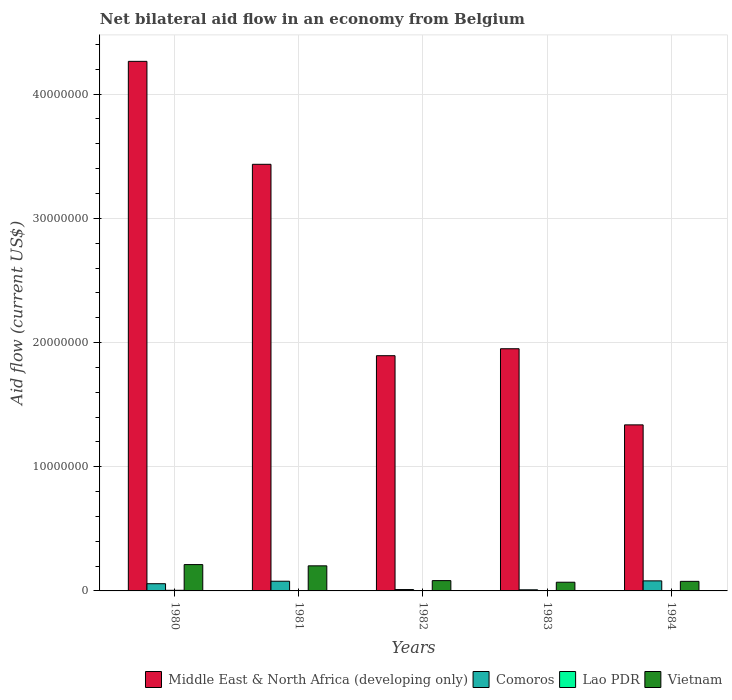Are the number of bars per tick equal to the number of legend labels?
Give a very brief answer. Yes. How many bars are there on the 5th tick from the left?
Provide a succinct answer. 4. What is the label of the 2nd group of bars from the left?
Provide a short and direct response. 1981. What is the net bilateral aid flow in Comoros in 1982?
Your response must be concise. 1.10e+05. Across all years, what is the maximum net bilateral aid flow in Vietnam?
Offer a terse response. 2.12e+06. Across all years, what is the minimum net bilateral aid flow in Middle East & North Africa (developing only)?
Offer a very short reply. 1.34e+07. In which year was the net bilateral aid flow in Vietnam maximum?
Provide a short and direct response. 1980. In which year was the net bilateral aid flow in Vietnam minimum?
Offer a very short reply. 1983. What is the total net bilateral aid flow in Middle East & North Africa (developing only) in the graph?
Your response must be concise. 1.29e+08. What is the difference between the net bilateral aid flow in Middle East & North Africa (developing only) in 1980 and that in 1983?
Provide a succinct answer. 2.31e+07. What is the difference between the net bilateral aid flow in Vietnam in 1982 and the net bilateral aid flow in Middle East & North Africa (developing only) in 1980?
Make the answer very short. -4.18e+07. What is the average net bilateral aid flow in Middle East & North Africa (developing only) per year?
Your answer should be compact. 2.58e+07. In the year 1984, what is the difference between the net bilateral aid flow in Middle East & North Africa (developing only) and net bilateral aid flow in Vietnam?
Keep it short and to the point. 1.26e+07. What is the ratio of the net bilateral aid flow in Lao PDR in 1982 to that in 1983?
Your response must be concise. 3. What is the difference between the highest and the lowest net bilateral aid flow in Lao PDR?
Your response must be concise. 4.00e+04. Is the sum of the net bilateral aid flow in Middle East & North Africa (developing only) in 1981 and 1983 greater than the maximum net bilateral aid flow in Comoros across all years?
Your response must be concise. Yes. What does the 1st bar from the left in 1980 represents?
Your response must be concise. Middle East & North Africa (developing only). What does the 3rd bar from the right in 1983 represents?
Offer a very short reply. Comoros. How many bars are there?
Your answer should be very brief. 20. Are all the bars in the graph horizontal?
Offer a very short reply. No. How many years are there in the graph?
Give a very brief answer. 5. Are the values on the major ticks of Y-axis written in scientific E-notation?
Provide a short and direct response. No. Does the graph contain any zero values?
Give a very brief answer. No. Where does the legend appear in the graph?
Keep it short and to the point. Bottom right. How many legend labels are there?
Offer a very short reply. 4. How are the legend labels stacked?
Offer a terse response. Horizontal. What is the title of the graph?
Make the answer very short. Net bilateral aid flow in an economy from Belgium. Does "Ghana" appear as one of the legend labels in the graph?
Ensure brevity in your answer.  No. What is the label or title of the X-axis?
Your answer should be compact. Years. What is the Aid flow (current US$) in Middle East & North Africa (developing only) in 1980?
Provide a short and direct response. 4.26e+07. What is the Aid flow (current US$) in Comoros in 1980?
Give a very brief answer. 5.80e+05. What is the Aid flow (current US$) in Vietnam in 1980?
Your answer should be compact. 2.12e+06. What is the Aid flow (current US$) of Middle East & North Africa (developing only) in 1981?
Keep it short and to the point. 3.44e+07. What is the Aid flow (current US$) of Comoros in 1981?
Offer a terse response. 7.80e+05. What is the Aid flow (current US$) of Lao PDR in 1981?
Provide a succinct answer. 10000. What is the Aid flow (current US$) in Vietnam in 1981?
Provide a succinct answer. 2.02e+06. What is the Aid flow (current US$) in Middle East & North Africa (developing only) in 1982?
Provide a short and direct response. 1.89e+07. What is the Aid flow (current US$) in Comoros in 1982?
Offer a terse response. 1.10e+05. What is the Aid flow (current US$) in Vietnam in 1982?
Make the answer very short. 8.30e+05. What is the Aid flow (current US$) of Middle East & North Africa (developing only) in 1983?
Keep it short and to the point. 1.95e+07. What is the Aid flow (current US$) of Vietnam in 1983?
Give a very brief answer. 7.00e+05. What is the Aid flow (current US$) of Middle East & North Africa (developing only) in 1984?
Ensure brevity in your answer.  1.34e+07. What is the Aid flow (current US$) in Comoros in 1984?
Your response must be concise. 8.10e+05. What is the Aid flow (current US$) in Vietnam in 1984?
Provide a succinct answer. 7.70e+05. Across all years, what is the maximum Aid flow (current US$) of Middle East & North Africa (developing only)?
Your response must be concise. 4.26e+07. Across all years, what is the maximum Aid flow (current US$) in Comoros?
Ensure brevity in your answer.  8.10e+05. Across all years, what is the maximum Aid flow (current US$) in Lao PDR?
Give a very brief answer. 5.00e+04. Across all years, what is the maximum Aid flow (current US$) in Vietnam?
Provide a succinct answer. 2.12e+06. Across all years, what is the minimum Aid flow (current US$) in Middle East & North Africa (developing only)?
Offer a terse response. 1.34e+07. Across all years, what is the minimum Aid flow (current US$) in Lao PDR?
Provide a short and direct response. 10000. What is the total Aid flow (current US$) of Middle East & North Africa (developing only) in the graph?
Your answer should be compact. 1.29e+08. What is the total Aid flow (current US$) in Comoros in the graph?
Provide a short and direct response. 2.37e+06. What is the total Aid flow (current US$) of Lao PDR in the graph?
Provide a succinct answer. 1.20e+05. What is the total Aid flow (current US$) of Vietnam in the graph?
Offer a very short reply. 6.44e+06. What is the difference between the Aid flow (current US$) in Middle East & North Africa (developing only) in 1980 and that in 1981?
Provide a short and direct response. 8.29e+06. What is the difference between the Aid flow (current US$) in Middle East & North Africa (developing only) in 1980 and that in 1982?
Provide a short and direct response. 2.37e+07. What is the difference between the Aid flow (current US$) of Comoros in 1980 and that in 1982?
Offer a terse response. 4.70e+05. What is the difference between the Aid flow (current US$) of Vietnam in 1980 and that in 1982?
Keep it short and to the point. 1.29e+06. What is the difference between the Aid flow (current US$) of Middle East & North Africa (developing only) in 1980 and that in 1983?
Offer a very short reply. 2.31e+07. What is the difference between the Aid flow (current US$) of Comoros in 1980 and that in 1983?
Your response must be concise. 4.90e+05. What is the difference between the Aid flow (current US$) of Vietnam in 1980 and that in 1983?
Your answer should be compact. 1.42e+06. What is the difference between the Aid flow (current US$) in Middle East & North Africa (developing only) in 1980 and that in 1984?
Your answer should be compact. 2.93e+07. What is the difference between the Aid flow (current US$) of Comoros in 1980 and that in 1984?
Ensure brevity in your answer.  -2.30e+05. What is the difference between the Aid flow (current US$) in Vietnam in 1980 and that in 1984?
Offer a terse response. 1.35e+06. What is the difference between the Aid flow (current US$) of Middle East & North Africa (developing only) in 1981 and that in 1982?
Ensure brevity in your answer.  1.54e+07. What is the difference between the Aid flow (current US$) in Comoros in 1981 and that in 1982?
Your response must be concise. 6.70e+05. What is the difference between the Aid flow (current US$) of Lao PDR in 1981 and that in 1982?
Offer a terse response. -2.00e+04. What is the difference between the Aid flow (current US$) of Vietnam in 1981 and that in 1982?
Your answer should be compact. 1.19e+06. What is the difference between the Aid flow (current US$) in Middle East & North Africa (developing only) in 1981 and that in 1983?
Your response must be concise. 1.48e+07. What is the difference between the Aid flow (current US$) in Comoros in 1981 and that in 1983?
Make the answer very short. 6.90e+05. What is the difference between the Aid flow (current US$) of Vietnam in 1981 and that in 1983?
Keep it short and to the point. 1.32e+06. What is the difference between the Aid flow (current US$) of Middle East & North Africa (developing only) in 1981 and that in 1984?
Provide a short and direct response. 2.10e+07. What is the difference between the Aid flow (current US$) in Comoros in 1981 and that in 1984?
Offer a very short reply. -3.00e+04. What is the difference between the Aid flow (current US$) of Lao PDR in 1981 and that in 1984?
Make the answer very short. -10000. What is the difference between the Aid flow (current US$) in Vietnam in 1981 and that in 1984?
Provide a succinct answer. 1.25e+06. What is the difference between the Aid flow (current US$) in Middle East & North Africa (developing only) in 1982 and that in 1983?
Offer a very short reply. -5.60e+05. What is the difference between the Aid flow (current US$) in Lao PDR in 1982 and that in 1983?
Make the answer very short. 2.00e+04. What is the difference between the Aid flow (current US$) of Middle East & North Africa (developing only) in 1982 and that in 1984?
Give a very brief answer. 5.57e+06. What is the difference between the Aid flow (current US$) in Comoros in 1982 and that in 1984?
Ensure brevity in your answer.  -7.00e+05. What is the difference between the Aid flow (current US$) in Middle East & North Africa (developing only) in 1983 and that in 1984?
Your response must be concise. 6.13e+06. What is the difference between the Aid flow (current US$) in Comoros in 1983 and that in 1984?
Keep it short and to the point. -7.20e+05. What is the difference between the Aid flow (current US$) in Lao PDR in 1983 and that in 1984?
Offer a terse response. -10000. What is the difference between the Aid flow (current US$) of Vietnam in 1983 and that in 1984?
Your answer should be compact. -7.00e+04. What is the difference between the Aid flow (current US$) of Middle East & North Africa (developing only) in 1980 and the Aid flow (current US$) of Comoros in 1981?
Make the answer very short. 4.19e+07. What is the difference between the Aid flow (current US$) of Middle East & North Africa (developing only) in 1980 and the Aid flow (current US$) of Lao PDR in 1981?
Ensure brevity in your answer.  4.26e+07. What is the difference between the Aid flow (current US$) of Middle East & North Africa (developing only) in 1980 and the Aid flow (current US$) of Vietnam in 1981?
Give a very brief answer. 4.06e+07. What is the difference between the Aid flow (current US$) in Comoros in 1980 and the Aid flow (current US$) in Lao PDR in 1981?
Ensure brevity in your answer.  5.70e+05. What is the difference between the Aid flow (current US$) in Comoros in 1980 and the Aid flow (current US$) in Vietnam in 1981?
Provide a succinct answer. -1.44e+06. What is the difference between the Aid flow (current US$) in Lao PDR in 1980 and the Aid flow (current US$) in Vietnam in 1981?
Ensure brevity in your answer.  -1.97e+06. What is the difference between the Aid flow (current US$) in Middle East & North Africa (developing only) in 1980 and the Aid flow (current US$) in Comoros in 1982?
Your answer should be very brief. 4.25e+07. What is the difference between the Aid flow (current US$) of Middle East & North Africa (developing only) in 1980 and the Aid flow (current US$) of Lao PDR in 1982?
Keep it short and to the point. 4.26e+07. What is the difference between the Aid flow (current US$) in Middle East & North Africa (developing only) in 1980 and the Aid flow (current US$) in Vietnam in 1982?
Keep it short and to the point. 4.18e+07. What is the difference between the Aid flow (current US$) of Comoros in 1980 and the Aid flow (current US$) of Lao PDR in 1982?
Give a very brief answer. 5.50e+05. What is the difference between the Aid flow (current US$) of Lao PDR in 1980 and the Aid flow (current US$) of Vietnam in 1982?
Give a very brief answer. -7.80e+05. What is the difference between the Aid flow (current US$) in Middle East & North Africa (developing only) in 1980 and the Aid flow (current US$) in Comoros in 1983?
Your answer should be compact. 4.26e+07. What is the difference between the Aid flow (current US$) in Middle East & North Africa (developing only) in 1980 and the Aid flow (current US$) in Lao PDR in 1983?
Your response must be concise. 4.26e+07. What is the difference between the Aid flow (current US$) in Middle East & North Africa (developing only) in 1980 and the Aid flow (current US$) in Vietnam in 1983?
Provide a short and direct response. 4.19e+07. What is the difference between the Aid flow (current US$) in Comoros in 1980 and the Aid flow (current US$) in Lao PDR in 1983?
Your answer should be compact. 5.70e+05. What is the difference between the Aid flow (current US$) in Lao PDR in 1980 and the Aid flow (current US$) in Vietnam in 1983?
Provide a short and direct response. -6.50e+05. What is the difference between the Aid flow (current US$) of Middle East & North Africa (developing only) in 1980 and the Aid flow (current US$) of Comoros in 1984?
Give a very brief answer. 4.18e+07. What is the difference between the Aid flow (current US$) in Middle East & North Africa (developing only) in 1980 and the Aid flow (current US$) in Lao PDR in 1984?
Keep it short and to the point. 4.26e+07. What is the difference between the Aid flow (current US$) in Middle East & North Africa (developing only) in 1980 and the Aid flow (current US$) in Vietnam in 1984?
Provide a succinct answer. 4.19e+07. What is the difference between the Aid flow (current US$) of Comoros in 1980 and the Aid flow (current US$) of Lao PDR in 1984?
Provide a succinct answer. 5.60e+05. What is the difference between the Aid flow (current US$) in Comoros in 1980 and the Aid flow (current US$) in Vietnam in 1984?
Provide a succinct answer. -1.90e+05. What is the difference between the Aid flow (current US$) of Lao PDR in 1980 and the Aid flow (current US$) of Vietnam in 1984?
Your answer should be compact. -7.20e+05. What is the difference between the Aid flow (current US$) of Middle East & North Africa (developing only) in 1981 and the Aid flow (current US$) of Comoros in 1982?
Your answer should be very brief. 3.42e+07. What is the difference between the Aid flow (current US$) of Middle East & North Africa (developing only) in 1981 and the Aid flow (current US$) of Lao PDR in 1982?
Offer a terse response. 3.43e+07. What is the difference between the Aid flow (current US$) of Middle East & North Africa (developing only) in 1981 and the Aid flow (current US$) of Vietnam in 1982?
Your answer should be compact. 3.35e+07. What is the difference between the Aid flow (current US$) in Comoros in 1981 and the Aid flow (current US$) in Lao PDR in 1982?
Your answer should be very brief. 7.50e+05. What is the difference between the Aid flow (current US$) of Lao PDR in 1981 and the Aid flow (current US$) of Vietnam in 1982?
Your answer should be very brief. -8.20e+05. What is the difference between the Aid flow (current US$) in Middle East & North Africa (developing only) in 1981 and the Aid flow (current US$) in Comoros in 1983?
Provide a succinct answer. 3.43e+07. What is the difference between the Aid flow (current US$) in Middle East & North Africa (developing only) in 1981 and the Aid flow (current US$) in Lao PDR in 1983?
Your response must be concise. 3.43e+07. What is the difference between the Aid flow (current US$) of Middle East & North Africa (developing only) in 1981 and the Aid flow (current US$) of Vietnam in 1983?
Provide a succinct answer. 3.36e+07. What is the difference between the Aid flow (current US$) in Comoros in 1981 and the Aid flow (current US$) in Lao PDR in 1983?
Offer a very short reply. 7.70e+05. What is the difference between the Aid flow (current US$) of Comoros in 1981 and the Aid flow (current US$) of Vietnam in 1983?
Your answer should be compact. 8.00e+04. What is the difference between the Aid flow (current US$) of Lao PDR in 1981 and the Aid flow (current US$) of Vietnam in 1983?
Ensure brevity in your answer.  -6.90e+05. What is the difference between the Aid flow (current US$) in Middle East & North Africa (developing only) in 1981 and the Aid flow (current US$) in Comoros in 1984?
Offer a very short reply. 3.35e+07. What is the difference between the Aid flow (current US$) of Middle East & North Africa (developing only) in 1981 and the Aid flow (current US$) of Lao PDR in 1984?
Your response must be concise. 3.43e+07. What is the difference between the Aid flow (current US$) in Middle East & North Africa (developing only) in 1981 and the Aid flow (current US$) in Vietnam in 1984?
Make the answer very short. 3.36e+07. What is the difference between the Aid flow (current US$) of Comoros in 1981 and the Aid flow (current US$) of Lao PDR in 1984?
Provide a succinct answer. 7.60e+05. What is the difference between the Aid flow (current US$) in Lao PDR in 1981 and the Aid flow (current US$) in Vietnam in 1984?
Your answer should be very brief. -7.60e+05. What is the difference between the Aid flow (current US$) of Middle East & North Africa (developing only) in 1982 and the Aid flow (current US$) of Comoros in 1983?
Provide a succinct answer. 1.88e+07. What is the difference between the Aid flow (current US$) of Middle East & North Africa (developing only) in 1982 and the Aid flow (current US$) of Lao PDR in 1983?
Give a very brief answer. 1.89e+07. What is the difference between the Aid flow (current US$) in Middle East & North Africa (developing only) in 1982 and the Aid flow (current US$) in Vietnam in 1983?
Ensure brevity in your answer.  1.82e+07. What is the difference between the Aid flow (current US$) in Comoros in 1982 and the Aid flow (current US$) in Lao PDR in 1983?
Your answer should be compact. 1.00e+05. What is the difference between the Aid flow (current US$) of Comoros in 1982 and the Aid flow (current US$) of Vietnam in 1983?
Offer a terse response. -5.90e+05. What is the difference between the Aid flow (current US$) in Lao PDR in 1982 and the Aid flow (current US$) in Vietnam in 1983?
Give a very brief answer. -6.70e+05. What is the difference between the Aid flow (current US$) of Middle East & North Africa (developing only) in 1982 and the Aid flow (current US$) of Comoros in 1984?
Provide a short and direct response. 1.81e+07. What is the difference between the Aid flow (current US$) in Middle East & North Africa (developing only) in 1982 and the Aid flow (current US$) in Lao PDR in 1984?
Offer a terse response. 1.89e+07. What is the difference between the Aid flow (current US$) of Middle East & North Africa (developing only) in 1982 and the Aid flow (current US$) of Vietnam in 1984?
Make the answer very short. 1.82e+07. What is the difference between the Aid flow (current US$) in Comoros in 1982 and the Aid flow (current US$) in Vietnam in 1984?
Keep it short and to the point. -6.60e+05. What is the difference between the Aid flow (current US$) of Lao PDR in 1982 and the Aid flow (current US$) of Vietnam in 1984?
Provide a short and direct response. -7.40e+05. What is the difference between the Aid flow (current US$) in Middle East & North Africa (developing only) in 1983 and the Aid flow (current US$) in Comoros in 1984?
Provide a short and direct response. 1.87e+07. What is the difference between the Aid flow (current US$) of Middle East & North Africa (developing only) in 1983 and the Aid flow (current US$) of Lao PDR in 1984?
Your answer should be very brief. 1.95e+07. What is the difference between the Aid flow (current US$) of Middle East & North Africa (developing only) in 1983 and the Aid flow (current US$) of Vietnam in 1984?
Your answer should be very brief. 1.87e+07. What is the difference between the Aid flow (current US$) in Comoros in 1983 and the Aid flow (current US$) in Lao PDR in 1984?
Make the answer very short. 7.00e+04. What is the difference between the Aid flow (current US$) of Comoros in 1983 and the Aid flow (current US$) of Vietnam in 1984?
Ensure brevity in your answer.  -6.80e+05. What is the difference between the Aid flow (current US$) in Lao PDR in 1983 and the Aid flow (current US$) in Vietnam in 1984?
Provide a short and direct response. -7.60e+05. What is the average Aid flow (current US$) in Middle East & North Africa (developing only) per year?
Offer a very short reply. 2.58e+07. What is the average Aid flow (current US$) of Comoros per year?
Make the answer very short. 4.74e+05. What is the average Aid flow (current US$) in Lao PDR per year?
Provide a succinct answer. 2.40e+04. What is the average Aid flow (current US$) in Vietnam per year?
Your response must be concise. 1.29e+06. In the year 1980, what is the difference between the Aid flow (current US$) in Middle East & North Africa (developing only) and Aid flow (current US$) in Comoros?
Make the answer very short. 4.21e+07. In the year 1980, what is the difference between the Aid flow (current US$) in Middle East & North Africa (developing only) and Aid flow (current US$) in Lao PDR?
Your answer should be compact. 4.26e+07. In the year 1980, what is the difference between the Aid flow (current US$) in Middle East & North Africa (developing only) and Aid flow (current US$) in Vietnam?
Your response must be concise. 4.05e+07. In the year 1980, what is the difference between the Aid flow (current US$) in Comoros and Aid flow (current US$) in Lao PDR?
Ensure brevity in your answer.  5.30e+05. In the year 1980, what is the difference between the Aid flow (current US$) in Comoros and Aid flow (current US$) in Vietnam?
Keep it short and to the point. -1.54e+06. In the year 1980, what is the difference between the Aid flow (current US$) of Lao PDR and Aid flow (current US$) of Vietnam?
Provide a succinct answer. -2.07e+06. In the year 1981, what is the difference between the Aid flow (current US$) of Middle East & North Africa (developing only) and Aid flow (current US$) of Comoros?
Provide a short and direct response. 3.36e+07. In the year 1981, what is the difference between the Aid flow (current US$) in Middle East & North Africa (developing only) and Aid flow (current US$) in Lao PDR?
Your answer should be compact. 3.43e+07. In the year 1981, what is the difference between the Aid flow (current US$) in Middle East & North Africa (developing only) and Aid flow (current US$) in Vietnam?
Provide a succinct answer. 3.23e+07. In the year 1981, what is the difference between the Aid flow (current US$) in Comoros and Aid flow (current US$) in Lao PDR?
Offer a very short reply. 7.70e+05. In the year 1981, what is the difference between the Aid flow (current US$) of Comoros and Aid flow (current US$) of Vietnam?
Ensure brevity in your answer.  -1.24e+06. In the year 1981, what is the difference between the Aid flow (current US$) of Lao PDR and Aid flow (current US$) of Vietnam?
Your response must be concise. -2.01e+06. In the year 1982, what is the difference between the Aid flow (current US$) in Middle East & North Africa (developing only) and Aid flow (current US$) in Comoros?
Give a very brief answer. 1.88e+07. In the year 1982, what is the difference between the Aid flow (current US$) of Middle East & North Africa (developing only) and Aid flow (current US$) of Lao PDR?
Offer a terse response. 1.89e+07. In the year 1982, what is the difference between the Aid flow (current US$) of Middle East & North Africa (developing only) and Aid flow (current US$) of Vietnam?
Provide a succinct answer. 1.81e+07. In the year 1982, what is the difference between the Aid flow (current US$) of Comoros and Aid flow (current US$) of Vietnam?
Provide a short and direct response. -7.20e+05. In the year 1982, what is the difference between the Aid flow (current US$) of Lao PDR and Aid flow (current US$) of Vietnam?
Offer a very short reply. -8.00e+05. In the year 1983, what is the difference between the Aid flow (current US$) in Middle East & North Africa (developing only) and Aid flow (current US$) in Comoros?
Provide a short and direct response. 1.94e+07. In the year 1983, what is the difference between the Aid flow (current US$) in Middle East & North Africa (developing only) and Aid flow (current US$) in Lao PDR?
Provide a succinct answer. 1.95e+07. In the year 1983, what is the difference between the Aid flow (current US$) of Middle East & North Africa (developing only) and Aid flow (current US$) of Vietnam?
Make the answer very short. 1.88e+07. In the year 1983, what is the difference between the Aid flow (current US$) in Comoros and Aid flow (current US$) in Vietnam?
Give a very brief answer. -6.10e+05. In the year 1983, what is the difference between the Aid flow (current US$) in Lao PDR and Aid flow (current US$) in Vietnam?
Ensure brevity in your answer.  -6.90e+05. In the year 1984, what is the difference between the Aid flow (current US$) of Middle East & North Africa (developing only) and Aid flow (current US$) of Comoros?
Your response must be concise. 1.26e+07. In the year 1984, what is the difference between the Aid flow (current US$) in Middle East & North Africa (developing only) and Aid flow (current US$) in Lao PDR?
Your response must be concise. 1.34e+07. In the year 1984, what is the difference between the Aid flow (current US$) in Middle East & North Africa (developing only) and Aid flow (current US$) in Vietnam?
Offer a very short reply. 1.26e+07. In the year 1984, what is the difference between the Aid flow (current US$) in Comoros and Aid flow (current US$) in Lao PDR?
Your answer should be compact. 7.90e+05. In the year 1984, what is the difference between the Aid flow (current US$) in Comoros and Aid flow (current US$) in Vietnam?
Ensure brevity in your answer.  4.00e+04. In the year 1984, what is the difference between the Aid flow (current US$) of Lao PDR and Aid flow (current US$) of Vietnam?
Your answer should be very brief. -7.50e+05. What is the ratio of the Aid flow (current US$) of Middle East & North Africa (developing only) in 1980 to that in 1981?
Ensure brevity in your answer.  1.24. What is the ratio of the Aid flow (current US$) in Comoros in 1980 to that in 1981?
Provide a short and direct response. 0.74. What is the ratio of the Aid flow (current US$) in Lao PDR in 1980 to that in 1981?
Offer a terse response. 5. What is the ratio of the Aid flow (current US$) in Vietnam in 1980 to that in 1981?
Your answer should be compact. 1.05. What is the ratio of the Aid flow (current US$) in Middle East & North Africa (developing only) in 1980 to that in 1982?
Provide a short and direct response. 2.25. What is the ratio of the Aid flow (current US$) of Comoros in 1980 to that in 1982?
Your answer should be compact. 5.27. What is the ratio of the Aid flow (current US$) in Vietnam in 1980 to that in 1982?
Provide a succinct answer. 2.55. What is the ratio of the Aid flow (current US$) in Middle East & North Africa (developing only) in 1980 to that in 1983?
Keep it short and to the point. 2.19. What is the ratio of the Aid flow (current US$) in Comoros in 1980 to that in 1983?
Your answer should be very brief. 6.44. What is the ratio of the Aid flow (current US$) in Vietnam in 1980 to that in 1983?
Offer a very short reply. 3.03. What is the ratio of the Aid flow (current US$) in Middle East & North Africa (developing only) in 1980 to that in 1984?
Offer a terse response. 3.19. What is the ratio of the Aid flow (current US$) in Comoros in 1980 to that in 1984?
Make the answer very short. 0.72. What is the ratio of the Aid flow (current US$) of Vietnam in 1980 to that in 1984?
Your answer should be compact. 2.75. What is the ratio of the Aid flow (current US$) in Middle East & North Africa (developing only) in 1981 to that in 1982?
Make the answer very short. 1.81. What is the ratio of the Aid flow (current US$) in Comoros in 1981 to that in 1982?
Make the answer very short. 7.09. What is the ratio of the Aid flow (current US$) of Lao PDR in 1981 to that in 1982?
Offer a terse response. 0.33. What is the ratio of the Aid flow (current US$) of Vietnam in 1981 to that in 1982?
Your response must be concise. 2.43. What is the ratio of the Aid flow (current US$) in Middle East & North Africa (developing only) in 1981 to that in 1983?
Your answer should be compact. 1.76. What is the ratio of the Aid flow (current US$) in Comoros in 1981 to that in 1983?
Ensure brevity in your answer.  8.67. What is the ratio of the Aid flow (current US$) of Lao PDR in 1981 to that in 1983?
Your response must be concise. 1. What is the ratio of the Aid flow (current US$) in Vietnam in 1981 to that in 1983?
Offer a very short reply. 2.89. What is the ratio of the Aid flow (current US$) of Middle East & North Africa (developing only) in 1981 to that in 1984?
Ensure brevity in your answer.  2.57. What is the ratio of the Aid flow (current US$) of Comoros in 1981 to that in 1984?
Ensure brevity in your answer.  0.96. What is the ratio of the Aid flow (current US$) of Lao PDR in 1981 to that in 1984?
Keep it short and to the point. 0.5. What is the ratio of the Aid flow (current US$) in Vietnam in 1981 to that in 1984?
Provide a short and direct response. 2.62. What is the ratio of the Aid flow (current US$) in Middle East & North Africa (developing only) in 1982 to that in 1983?
Provide a succinct answer. 0.97. What is the ratio of the Aid flow (current US$) of Comoros in 1982 to that in 1983?
Your answer should be very brief. 1.22. What is the ratio of the Aid flow (current US$) in Lao PDR in 1982 to that in 1983?
Give a very brief answer. 3. What is the ratio of the Aid flow (current US$) in Vietnam in 1982 to that in 1983?
Your answer should be compact. 1.19. What is the ratio of the Aid flow (current US$) of Middle East & North Africa (developing only) in 1982 to that in 1984?
Provide a short and direct response. 1.42. What is the ratio of the Aid flow (current US$) in Comoros in 1982 to that in 1984?
Provide a short and direct response. 0.14. What is the ratio of the Aid flow (current US$) in Vietnam in 1982 to that in 1984?
Your response must be concise. 1.08. What is the ratio of the Aid flow (current US$) of Middle East & North Africa (developing only) in 1983 to that in 1984?
Provide a short and direct response. 1.46. What is the ratio of the Aid flow (current US$) of Comoros in 1983 to that in 1984?
Your answer should be compact. 0.11. What is the ratio of the Aid flow (current US$) of Lao PDR in 1983 to that in 1984?
Give a very brief answer. 0.5. What is the ratio of the Aid flow (current US$) of Vietnam in 1983 to that in 1984?
Give a very brief answer. 0.91. What is the difference between the highest and the second highest Aid flow (current US$) in Middle East & North Africa (developing only)?
Your response must be concise. 8.29e+06. What is the difference between the highest and the second highest Aid flow (current US$) of Comoros?
Make the answer very short. 3.00e+04. What is the difference between the highest and the second highest Aid flow (current US$) in Lao PDR?
Provide a succinct answer. 2.00e+04. What is the difference between the highest and the second highest Aid flow (current US$) in Vietnam?
Provide a short and direct response. 1.00e+05. What is the difference between the highest and the lowest Aid flow (current US$) in Middle East & North Africa (developing only)?
Make the answer very short. 2.93e+07. What is the difference between the highest and the lowest Aid flow (current US$) of Comoros?
Make the answer very short. 7.20e+05. What is the difference between the highest and the lowest Aid flow (current US$) of Lao PDR?
Keep it short and to the point. 4.00e+04. What is the difference between the highest and the lowest Aid flow (current US$) in Vietnam?
Provide a short and direct response. 1.42e+06. 